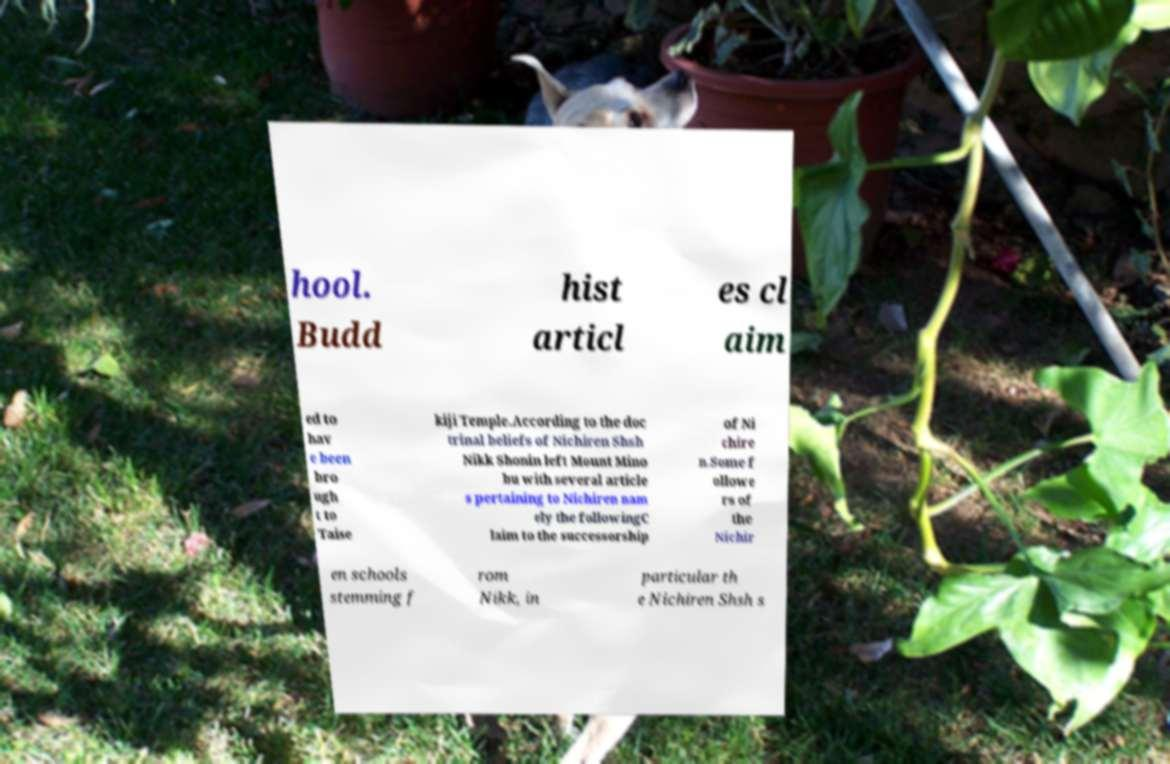For documentation purposes, I need the text within this image transcribed. Could you provide that? hool. Budd hist articl es cl aim ed to hav e been bro ugh t to Taise kiji Temple.According to the doc trinal beliefs of Nichiren Shsh Nikk Shonin left Mount Mino bu with several article s pertaining to Nichiren nam ely the followingC laim to the successorship of Ni chire n.Some f ollowe rs of the Nichir en schools stemming f rom Nikk, in particular th e Nichiren Shsh s 